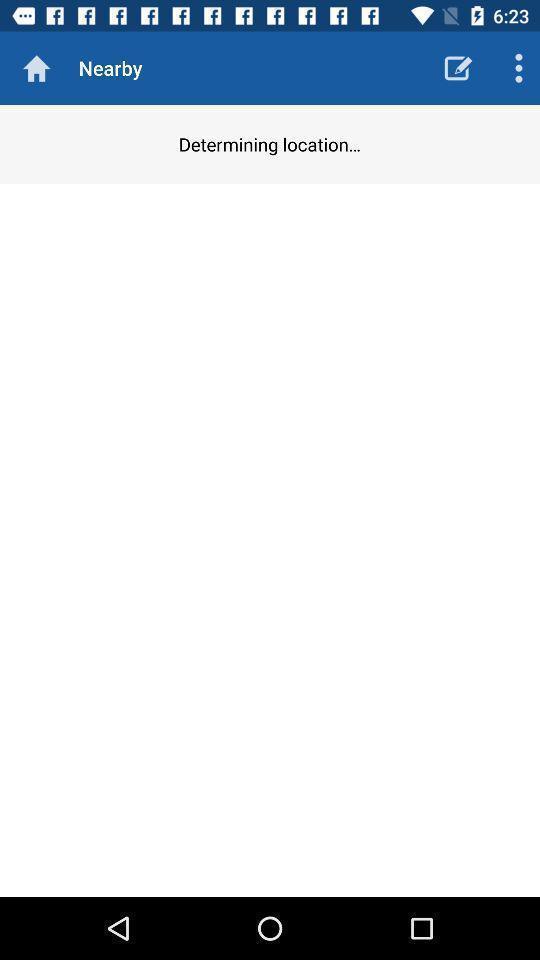Give me a narrative description of this picture. Page to find nearby location. 